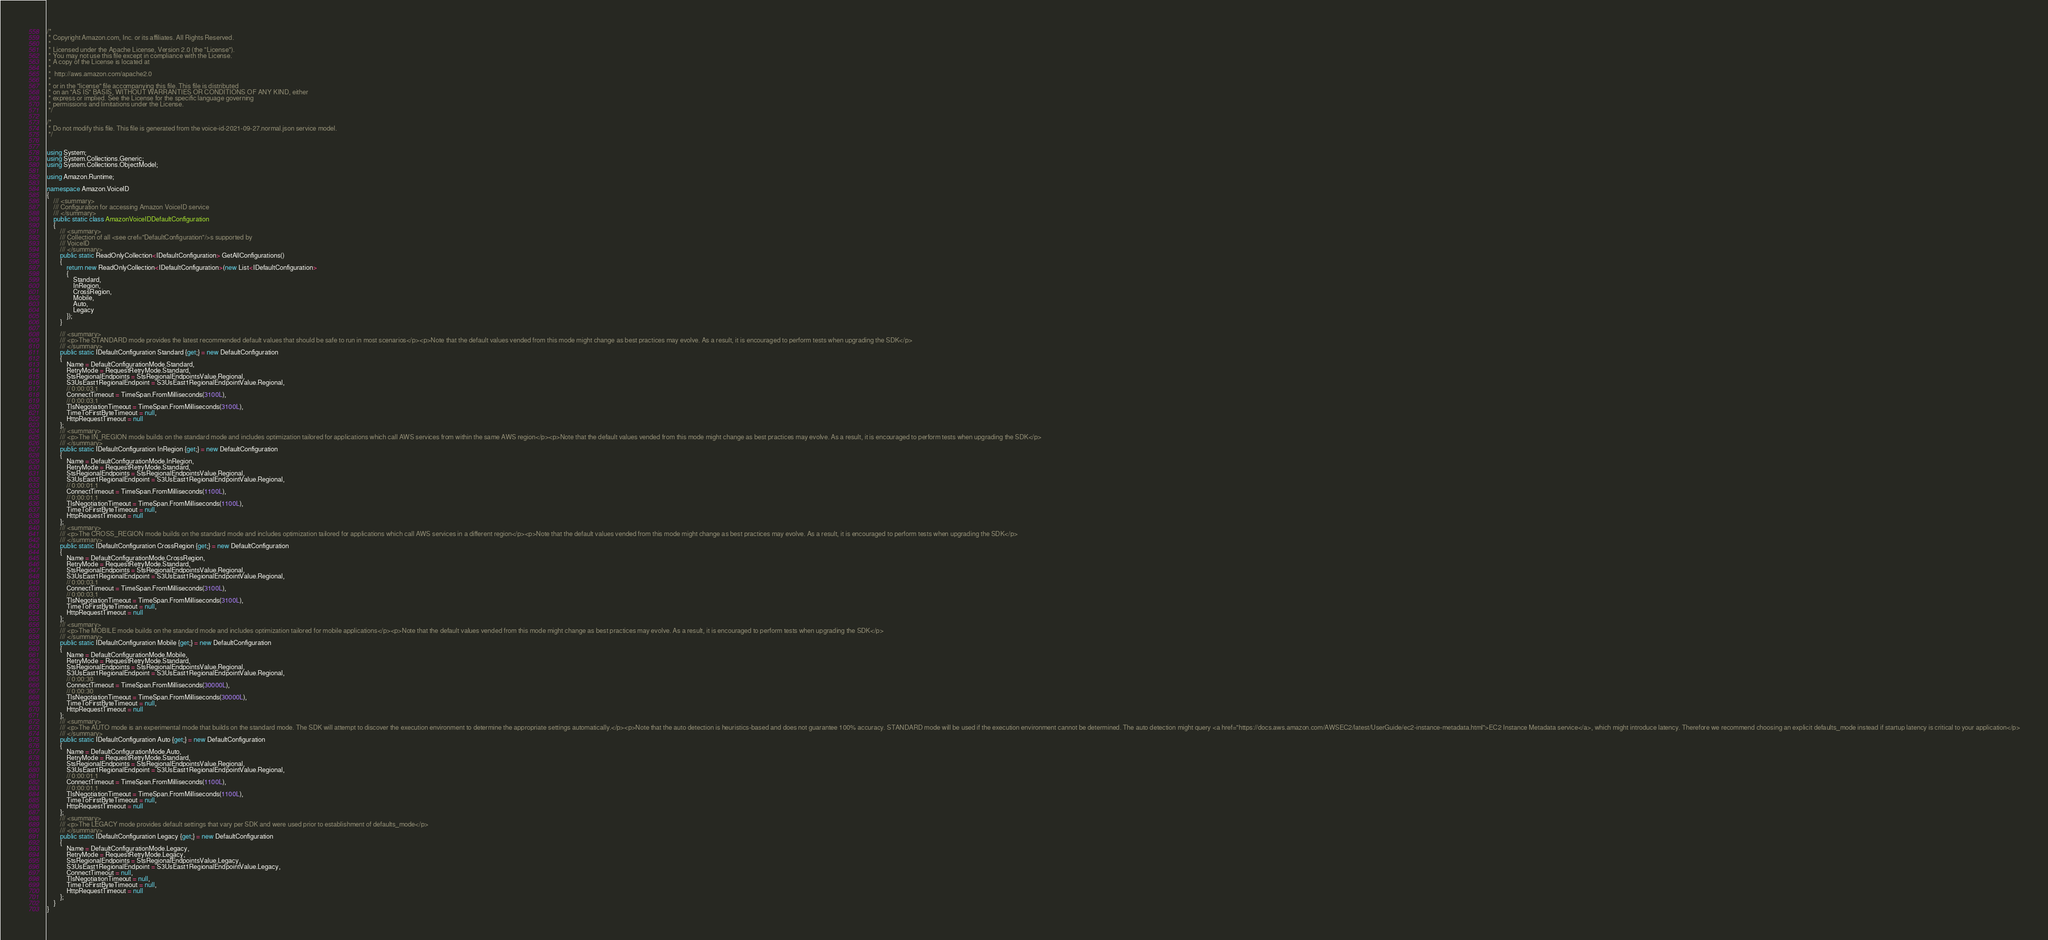Convert code to text. <code><loc_0><loc_0><loc_500><loc_500><_C#_>/*
 * Copyright Amazon.com, Inc. or its affiliates. All Rights Reserved.
 * 
 * Licensed under the Apache License, Version 2.0 (the "License").
 * You may not use this file except in compliance with the License.
 * A copy of the License is located at
 * 
 *  http://aws.amazon.com/apache2.0
 * 
 * or in the "license" file accompanying this file. This file is distributed
 * on an "AS IS" BASIS, WITHOUT WARRANTIES OR CONDITIONS OF ANY KIND, either
 * express or implied. See the License for the specific language governing
 * permissions and limitations under the License.
 */

/*
 * Do not modify this file. This file is generated from the voice-id-2021-09-27.normal.json service model.
 */


using System;
using System.Collections.Generic;
using System.Collections.ObjectModel;

using Amazon.Runtime;

namespace Amazon.VoiceID
{
    /// <summary>
    /// Configuration for accessing Amazon VoiceID service
    /// </summary>
    public static class AmazonVoiceIDDefaultConfiguration
    {
        /// <summary>
        /// Collection of all <see cref="DefaultConfiguration"/>s supported by
        /// VoiceID
        /// </summary>
        public static ReadOnlyCollection<IDefaultConfiguration> GetAllConfigurations()
        {
            return new ReadOnlyCollection<IDefaultConfiguration>(new List<IDefaultConfiguration>
            {
                Standard,
                InRegion,
                CrossRegion,
                Mobile,
                Auto,
                Legacy
            });
        }

        /// <summary>
        /// <p>The STANDARD mode provides the latest recommended default values that should be safe to run in most scenarios</p><p>Note that the default values vended from this mode might change as best practices may evolve. As a result, it is encouraged to perform tests when upgrading the SDK</p>
        /// </summary>
        public static IDefaultConfiguration Standard {get;} = new DefaultConfiguration
        {
            Name = DefaultConfigurationMode.Standard,
            RetryMode = RequestRetryMode.Standard,
            StsRegionalEndpoints = StsRegionalEndpointsValue.Regional,
            S3UsEast1RegionalEndpoint = S3UsEast1RegionalEndpointValue.Regional,
            // 0:00:03.1
            ConnectTimeout = TimeSpan.FromMilliseconds(3100L),
            // 0:00:03.1
            TlsNegotiationTimeout = TimeSpan.FromMilliseconds(3100L),
            TimeToFirstByteTimeout = null,
            HttpRequestTimeout = null
        };
        /// <summary>
        /// <p>The IN_REGION mode builds on the standard mode and includes optimization tailored for applications which call AWS services from within the same AWS region</p><p>Note that the default values vended from this mode might change as best practices may evolve. As a result, it is encouraged to perform tests when upgrading the SDK</p>
        /// </summary>
        public static IDefaultConfiguration InRegion {get;} = new DefaultConfiguration
        {
            Name = DefaultConfigurationMode.InRegion,
            RetryMode = RequestRetryMode.Standard,
            StsRegionalEndpoints = StsRegionalEndpointsValue.Regional,
            S3UsEast1RegionalEndpoint = S3UsEast1RegionalEndpointValue.Regional,
            // 0:00:01.1
            ConnectTimeout = TimeSpan.FromMilliseconds(1100L),
            // 0:00:01.1
            TlsNegotiationTimeout = TimeSpan.FromMilliseconds(1100L),
            TimeToFirstByteTimeout = null,
            HttpRequestTimeout = null
        };
        /// <summary>
        /// <p>The CROSS_REGION mode builds on the standard mode and includes optimization tailored for applications which call AWS services in a different region</p><p>Note that the default values vended from this mode might change as best practices may evolve. As a result, it is encouraged to perform tests when upgrading the SDK</p>
        /// </summary>
        public static IDefaultConfiguration CrossRegion {get;} = new DefaultConfiguration
        {
            Name = DefaultConfigurationMode.CrossRegion,
            RetryMode = RequestRetryMode.Standard,
            StsRegionalEndpoints = StsRegionalEndpointsValue.Regional,
            S3UsEast1RegionalEndpoint = S3UsEast1RegionalEndpointValue.Regional,
            // 0:00:03.1
            ConnectTimeout = TimeSpan.FromMilliseconds(3100L),
            // 0:00:03.1
            TlsNegotiationTimeout = TimeSpan.FromMilliseconds(3100L),
            TimeToFirstByteTimeout = null,
            HttpRequestTimeout = null
        };
        /// <summary>
        /// <p>The MOBILE mode builds on the standard mode and includes optimization tailored for mobile applications</p><p>Note that the default values vended from this mode might change as best practices may evolve. As a result, it is encouraged to perform tests when upgrading the SDK</p>
        /// </summary>
        public static IDefaultConfiguration Mobile {get;} = new DefaultConfiguration
        {
            Name = DefaultConfigurationMode.Mobile,
            RetryMode = RequestRetryMode.Standard,
            StsRegionalEndpoints = StsRegionalEndpointsValue.Regional,
            S3UsEast1RegionalEndpoint = S3UsEast1RegionalEndpointValue.Regional,
            // 0:00:30
            ConnectTimeout = TimeSpan.FromMilliseconds(30000L),
            // 0:00:30
            TlsNegotiationTimeout = TimeSpan.FromMilliseconds(30000L),
            TimeToFirstByteTimeout = null,
            HttpRequestTimeout = null
        };
        /// <summary>
        /// <p>The AUTO mode is an experimental mode that builds on the standard mode. The SDK will attempt to discover the execution environment to determine the appropriate settings automatically.</p><p>Note that the auto detection is heuristics-based and does not guarantee 100% accuracy. STANDARD mode will be used if the execution environment cannot be determined. The auto detection might query <a href="https://docs.aws.amazon.com/AWSEC2/latest/UserGuide/ec2-instance-metadata.html">EC2 Instance Metadata service</a>, which might introduce latency. Therefore we recommend choosing an explicit defaults_mode instead if startup latency is critical to your application</p>
        /// </summary>
        public static IDefaultConfiguration Auto {get;} = new DefaultConfiguration
        {
            Name = DefaultConfigurationMode.Auto,
            RetryMode = RequestRetryMode.Standard,
            StsRegionalEndpoints = StsRegionalEndpointsValue.Regional,
            S3UsEast1RegionalEndpoint = S3UsEast1RegionalEndpointValue.Regional,
            // 0:00:01.1
            ConnectTimeout = TimeSpan.FromMilliseconds(1100L),
            // 0:00:01.1
            TlsNegotiationTimeout = TimeSpan.FromMilliseconds(1100L),
            TimeToFirstByteTimeout = null,
            HttpRequestTimeout = null
        };
        /// <summary>
        /// <p>The LEGACY mode provides default settings that vary per SDK and were used prior to establishment of defaults_mode</p>
        /// </summary>
        public static IDefaultConfiguration Legacy {get;} = new DefaultConfiguration
        {
            Name = DefaultConfigurationMode.Legacy,
            RetryMode = RequestRetryMode.Legacy,
            StsRegionalEndpoints = StsRegionalEndpointsValue.Legacy,
            S3UsEast1RegionalEndpoint = S3UsEast1RegionalEndpointValue.Legacy,
            ConnectTimeout = null,
            TlsNegotiationTimeout = null,
            TimeToFirstByteTimeout = null,
            HttpRequestTimeout = null
        };
    }
}</code> 